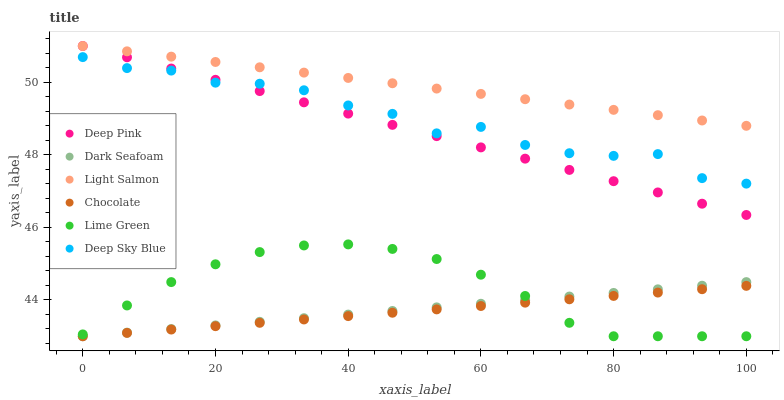Does Chocolate have the minimum area under the curve?
Answer yes or no. Yes. Does Light Salmon have the maximum area under the curve?
Answer yes or no. Yes. Does Deep Pink have the minimum area under the curve?
Answer yes or no. No. Does Deep Pink have the maximum area under the curve?
Answer yes or no. No. Is Chocolate the smoothest?
Answer yes or no. Yes. Is Deep Sky Blue the roughest?
Answer yes or no. Yes. Is Deep Pink the smoothest?
Answer yes or no. No. Is Deep Pink the roughest?
Answer yes or no. No. Does Chocolate have the lowest value?
Answer yes or no. Yes. Does Deep Pink have the lowest value?
Answer yes or no. No. Does Deep Pink have the highest value?
Answer yes or no. Yes. Does Chocolate have the highest value?
Answer yes or no. No. Is Chocolate less than Light Salmon?
Answer yes or no. Yes. Is Deep Pink greater than Dark Seafoam?
Answer yes or no. Yes. Does Dark Seafoam intersect Lime Green?
Answer yes or no. Yes. Is Dark Seafoam less than Lime Green?
Answer yes or no. No. Is Dark Seafoam greater than Lime Green?
Answer yes or no. No. Does Chocolate intersect Light Salmon?
Answer yes or no. No. 